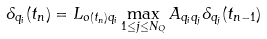Convert formula to latex. <formula><loc_0><loc_0><loc_500><loc_500>\delta _ { q _ { i } } ( t _ { n } ) = L _ { o ( t _ { n } ) q _ { i } } \max _ { 1 \leq j \leq N _ { Q } } A _ { q _ { i } q _ { j } } \delta _ { q _ { j } } ( t _ { n - 1 } )</formula> 